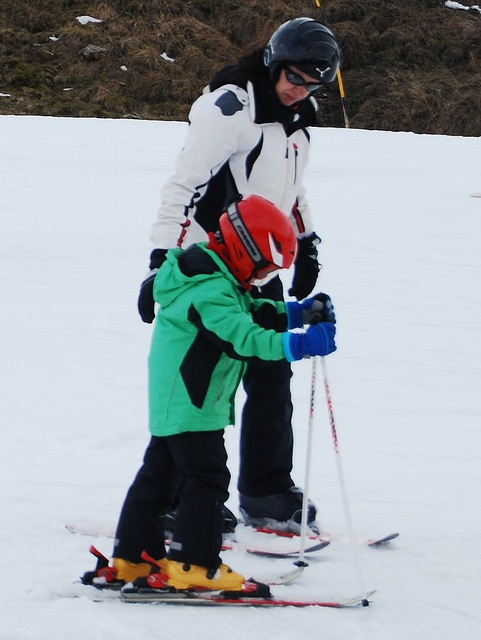Describe the objects in this image and their specific colors. I can see people in black, turquoise, teal, and brown tones, people in black, lightgray, and darkgray tones, skis in black, gray, darkgray, and lightgray tones, skis in black, lightgray, darkgray, and gray tones, and skis in black, maroon, gray, and darkgray tones in this image. 